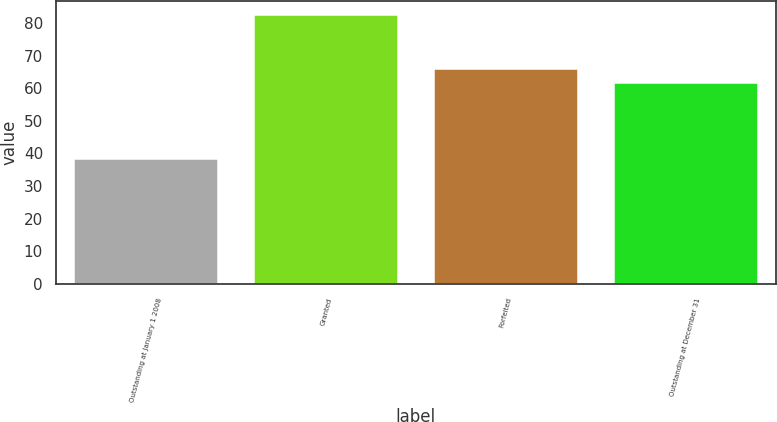Convert chart to OTSL. <chart><loc_0><loc_0><loc_500><loc_500><bar_chart><fcel>Outstanding at January 1 2008<fcel>Granted<fcel>Forfeited<fcel>Outstanding at December 31<nl><fcel>38.31<fcel>82.55<fcel>65.99<fcel>61.57<nl></chart> 